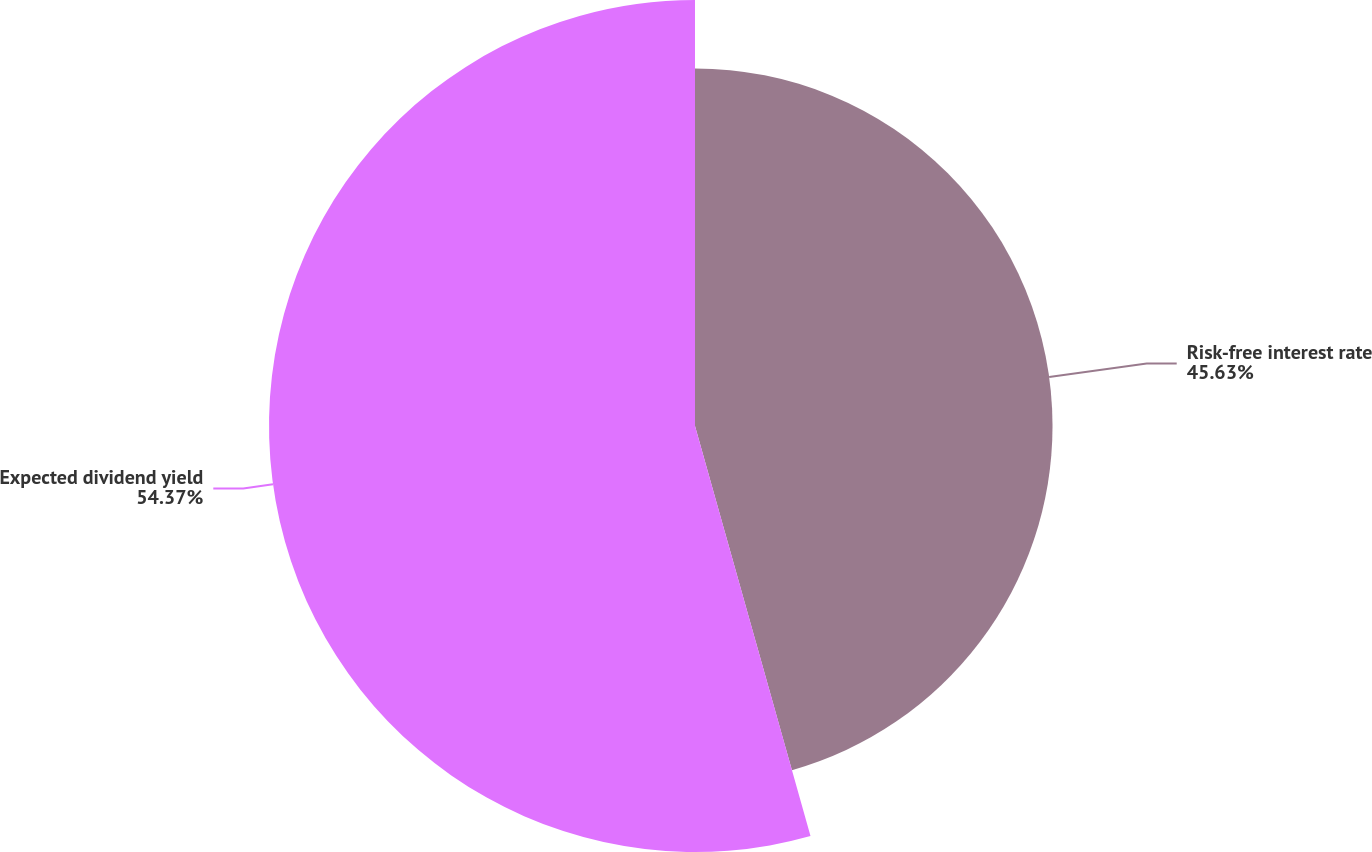Convert chart. <chart><loc_0><loc_0><loc_500><loc_500><pie_chart><fcel>Risk-free interest rate<fcel>Expected dividend yield<nl><fcel>45.63%<fcel>54.37%<nl></chart> 